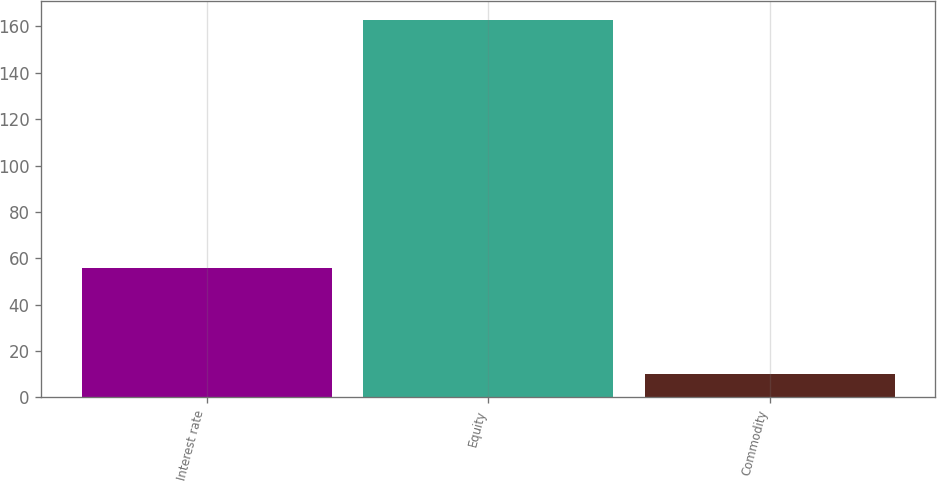Convert chart. <chart><loc_0><loc_0><loc_500><loc_500><bar_chart><fcel>Interest rate<fcel>Equity<fcel>Commodity<nl><fcel>56<fcel>163<fcel>10<nl></chart> 